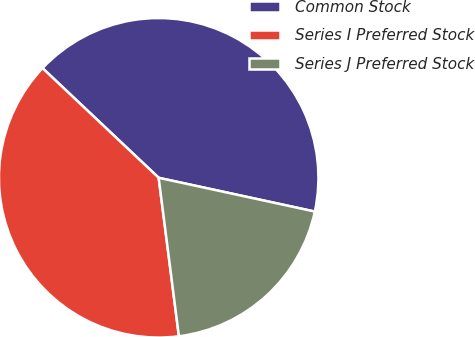<chart> <loc_0><loc_0><loc_500><loc_500><pie_chart><fcel>Common Stock<fcel>Series I Preferred Stock<fcel>Series J Preferred Stock<nl><fcel>41.35%<fcel>39.06%<fcel>19.59%<nl></chart> 